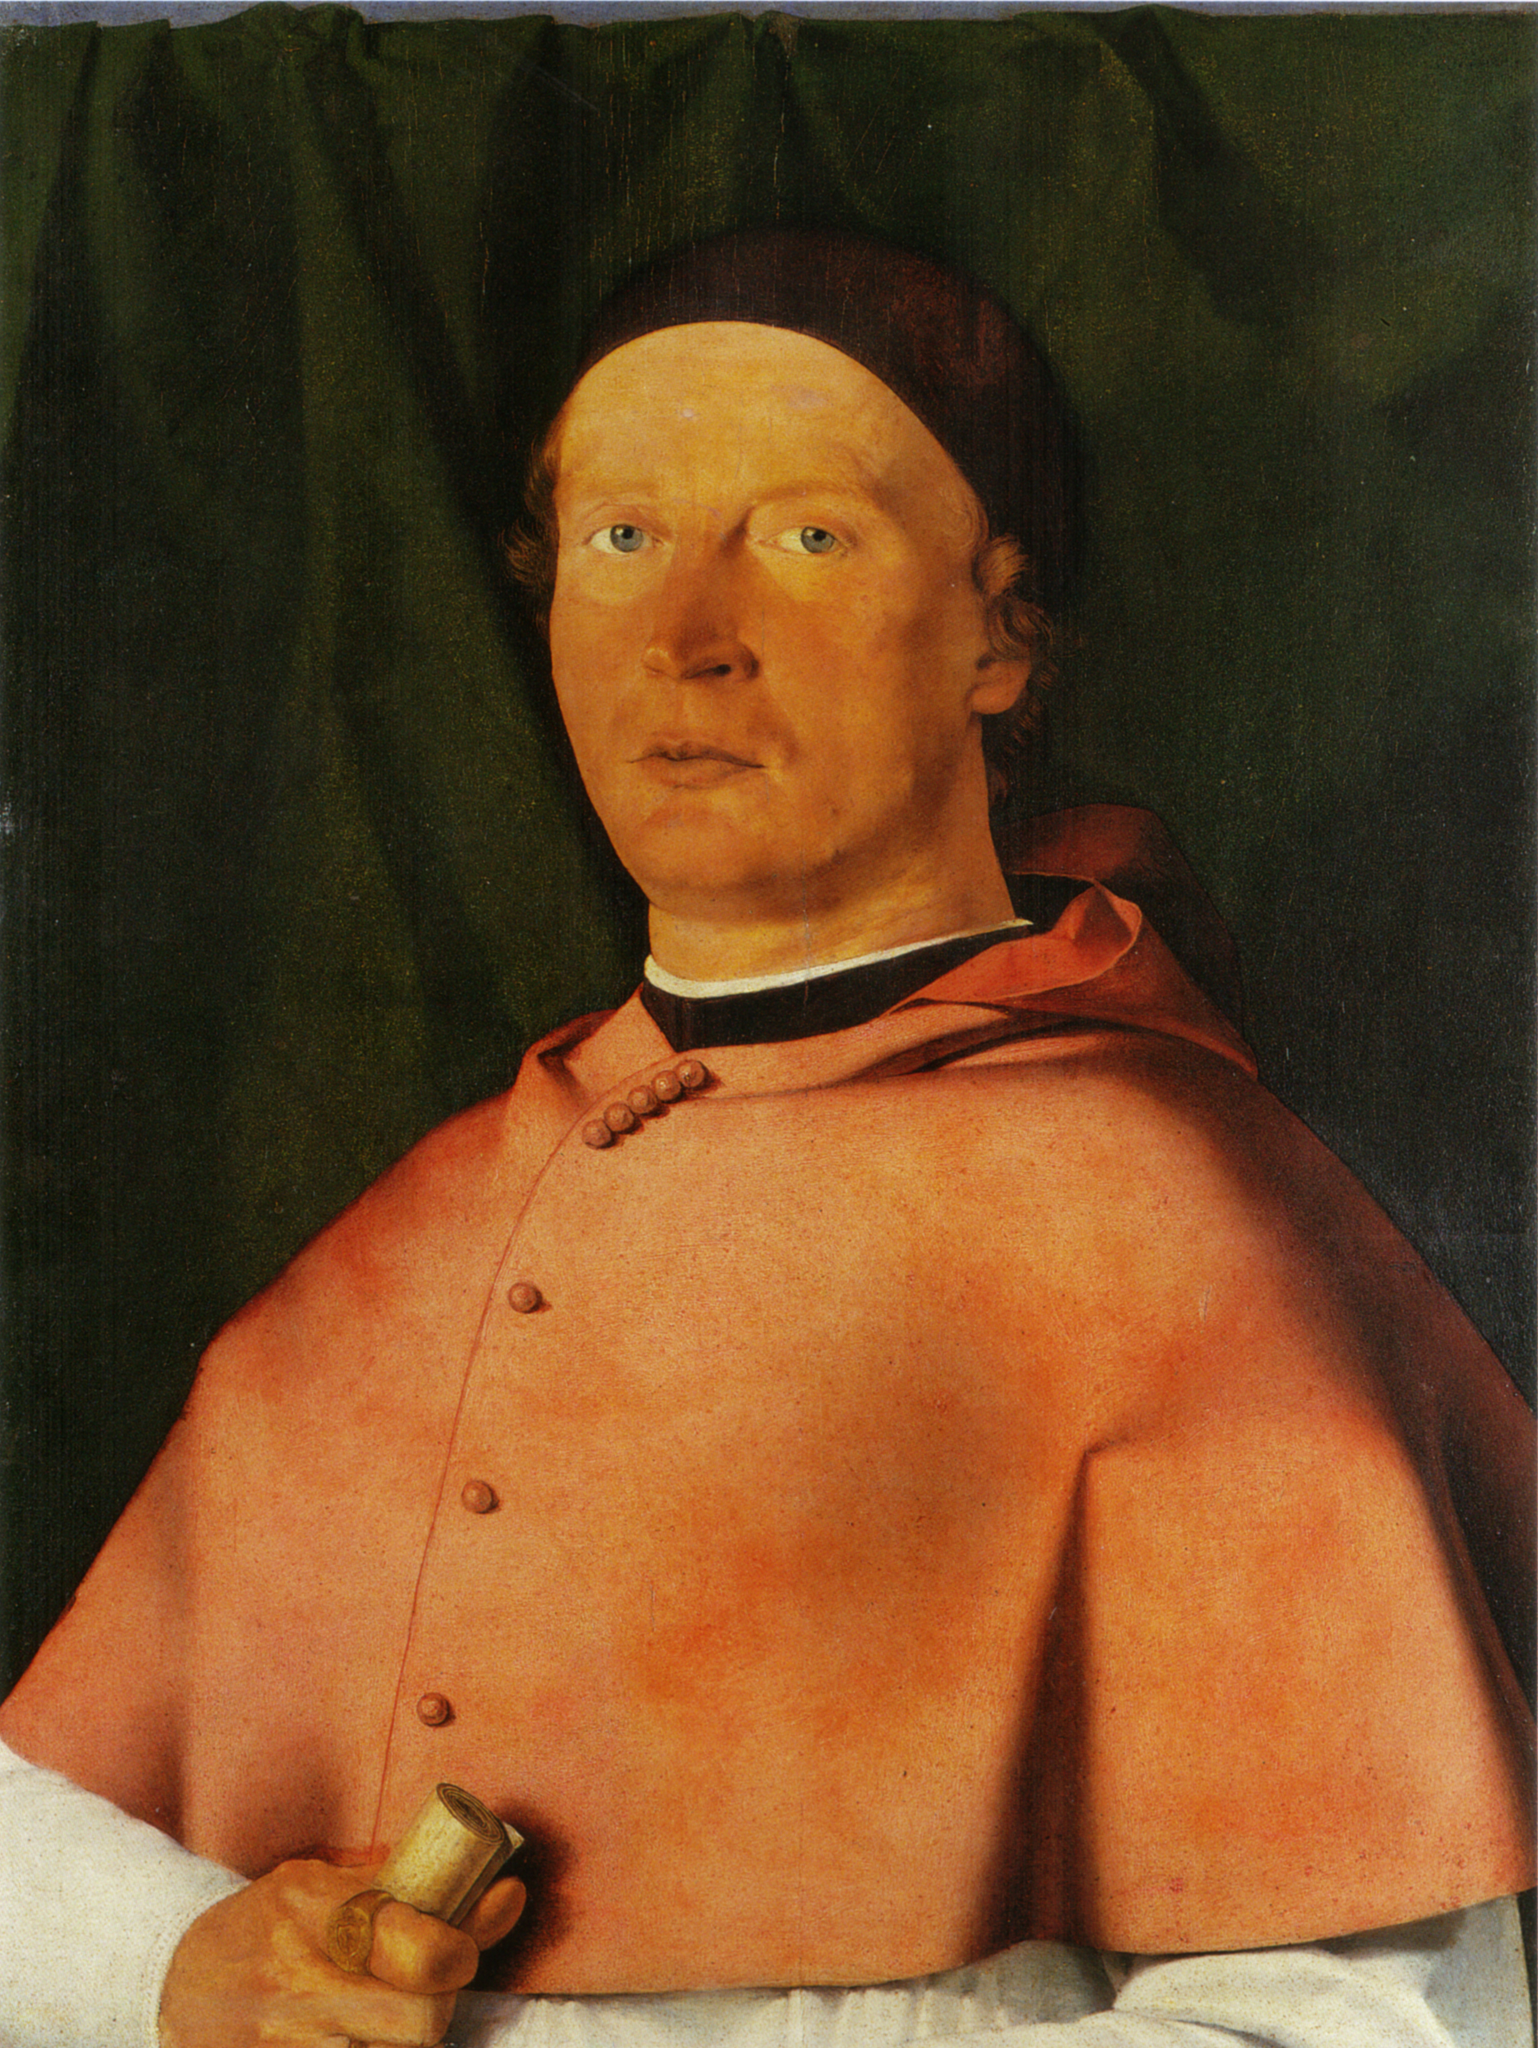What might the golden object he is holding represent? The object could be interpreted in a few ways depending on its actual use and the cultural context. It might be a religious artifact, a signet used to seal letters and decree important documents, or simply a personal item of value. Each of these possibilities enriches our understanding of the individual, suggesting that he was not only affluent but possibly involved in clerical duties or governance. Thus, the gold object emphasizes his authority and affluent status within his society. 